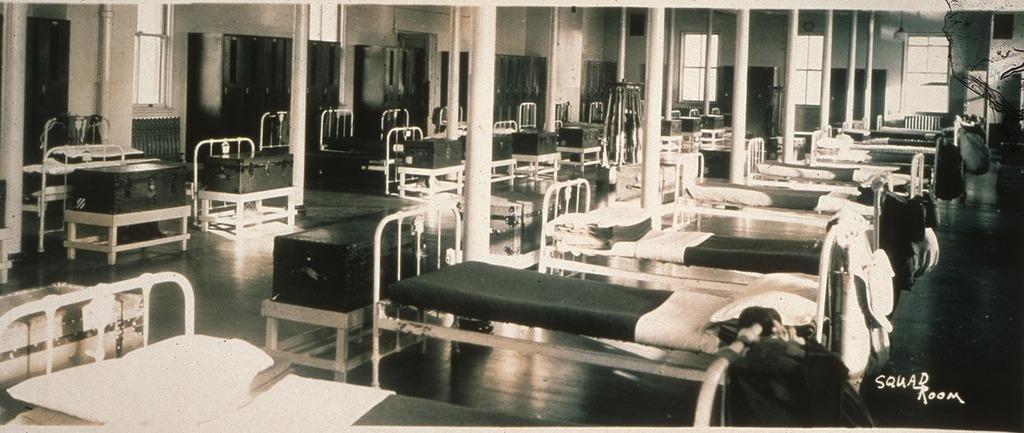What type of furniture is present in the image? There are beds in the image. What is placed on each bed? Each bed has a pillow on it. What other piece of furniture is visible beside the bed? There is a wooden box beside the bed. What can be seen in the background of the image? There are other objects visible in the background of the image. What type of trick is being performed with the wrist in the image? There is no trick or wrist movement visible in the image; it only shows beds, pillows, and a wooden box. 